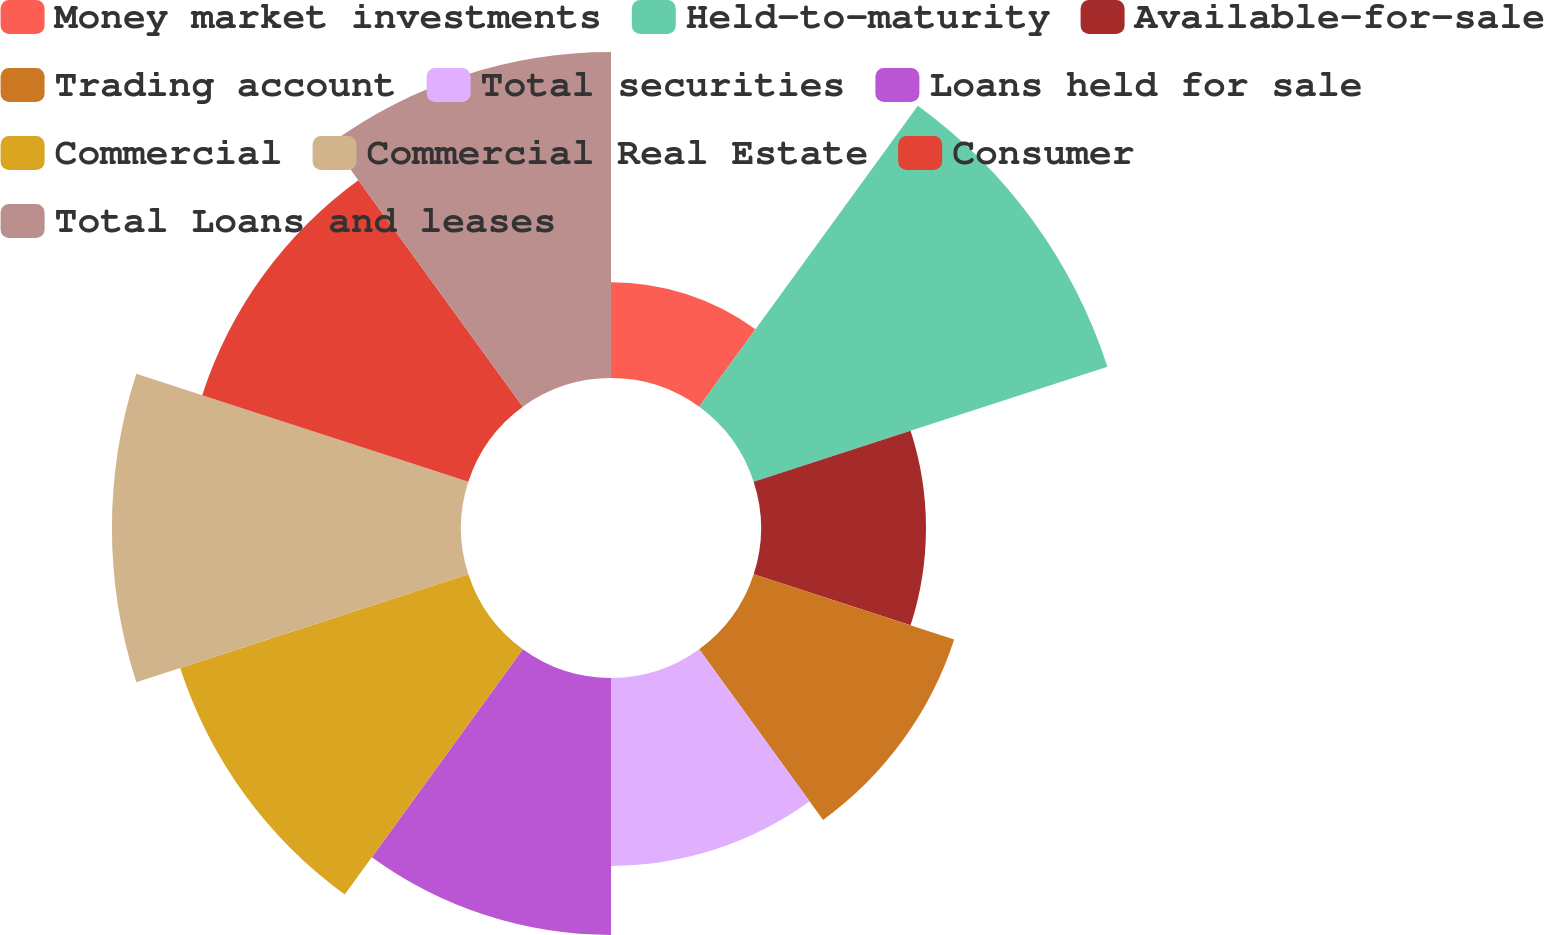Convert chart to OTSL. <chart><loc_0><loc_0><loc_500><loc_500><pie_chart><fcel>Money market investments<fcel>Held-to-maturity<fcel>Available-for-sale<fcel>Trading account<fcel>Total securities<fcel>Loans held for sale<fcel>Commercial<fcel>Commercial Real Estate<fcel>Consumer<fcel>Total Loans and leases<nl><fcel>3.76%<fcel>14.61%<fcel>6.48%<fcel>8.28%<fcel>7.38%<fcel>10.09%<fcel>11.9%<fcel>13.71%<fcel>10.99%<fcel>12.8%<nl></chart> 